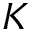<formula> <loc_0><loc_0><loc_500><loc_500>K</formula> 